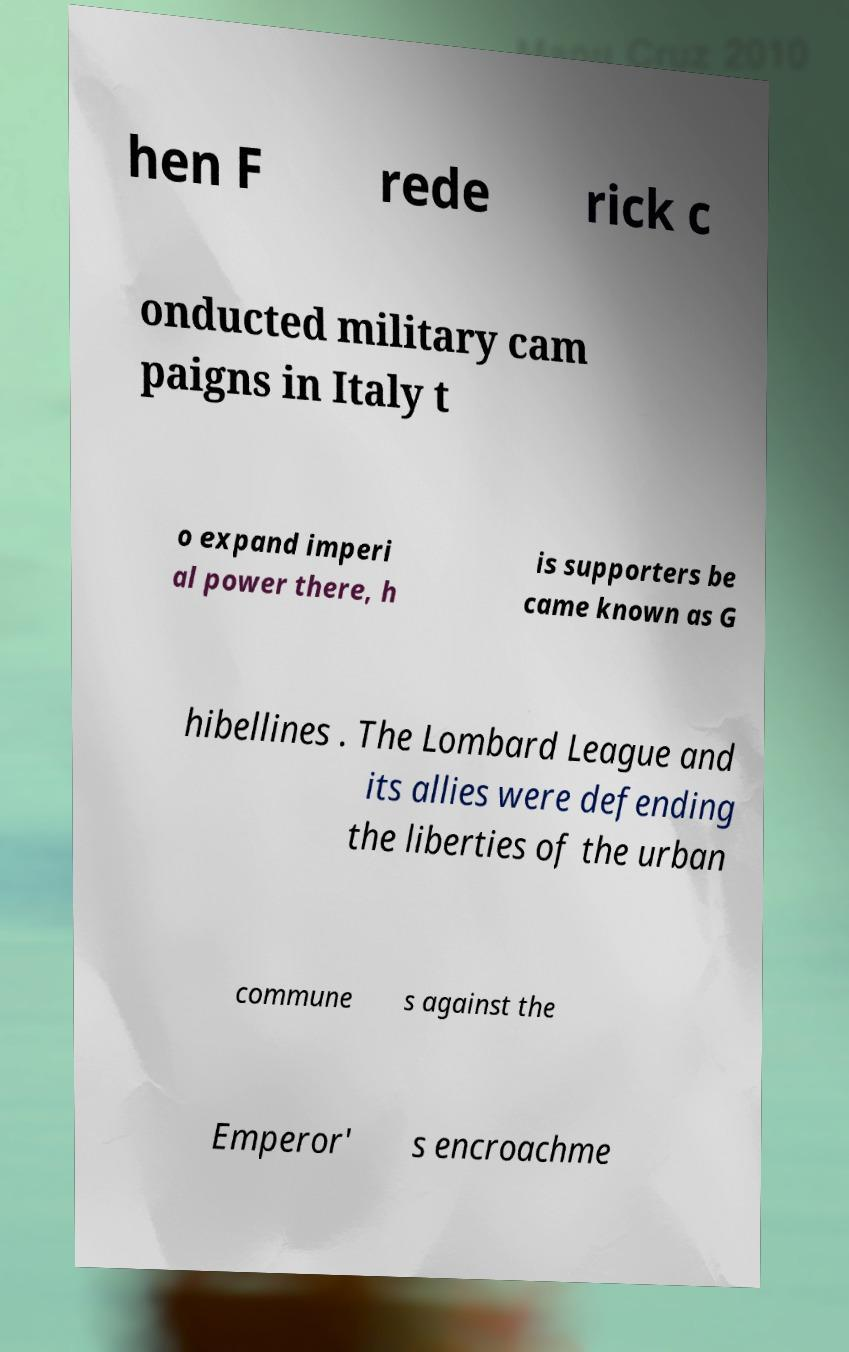There's text embedded in this image that I need extracted. Can you transcribe it verbatim? hen F rede rick c onducted military cam paigns in Italy t o expand imperi al power there, h is supporters be came known as G hibellines . The Lombard League and its allies were defending the liberties of the urban commune s against the Emperor' s encroachme 